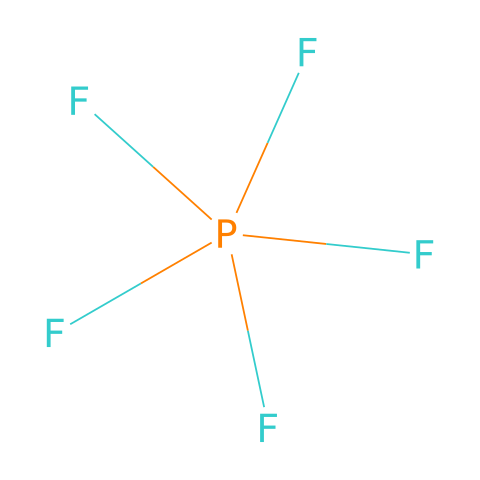What is the molecular formula of phosphorus hexafluoride? The SMILES notation indicates that the molecule comprises one phosphorus atom and six fluorine atoms, which leads us to the molecular formula as P(F)6.
Answer: PF6 How many total atoms are present in phosphorus hexafluoride? The molecular formula reveals one phosphorus atom and six fluorine atoms, leading to a total of seven atoms (1 + 6 = 7).
Answer: 7 Is phosphorus hexafluoride a Lewis acid or base? Phosphorus hexafluoride is a strong Lewis acid as indicated by its tendency to accept electron pairs due to the electron deficiency of the phosphorus atom.
Answer: Lewis acid What type of chemical bonding is predominantly present in phosphorus hexafluoride? The structure shows phosphorus bonded to six fluorine atoms through covalent bonds, where the electrons are shared between the phosphorus and fluorine atoms.
Answer: covalent What role does phosphorus play in phosphorus hexafluoride regarding valence shell? Phosphorus in this molecule has an expanded octet, utilizing d-orbitals to accommodate more than eight electrons around it, which facilitates its role as a Lewis acid.
Answer: expanded octet Does phosphorus hexafluoride exhibit any geometric symmetry? The structure of phosphorus hexafluoride displays octahedral symmetry, which is evident as six fluorine atoms are symmetrically arranged around the phosphorus atom.
Answer: octahedral symmetry 